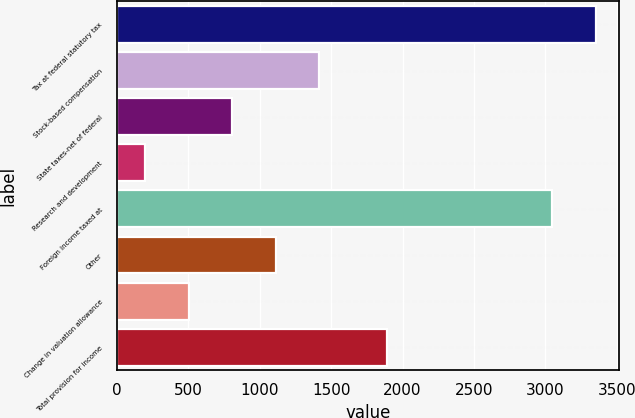Convert chart. <chart><loc_0><loc_0><loc_500><loc_500><bar_chart><fcel>Tax at federal statutory tax<fcel>Stock-based compensation<fcel>State taxes-net of federal<fcel>Research and development<fcel>Foreign income taxed at<fcel>Other<fcel>Change in valuation allowance<fcel>Total provision for income<nl><fcel>3350.8<fcel>1414.2<fcel>806.6<fcel>199<fcel>3047<fcel>1110.4<fcel>502.8<fcel>1888<nl></chart> 